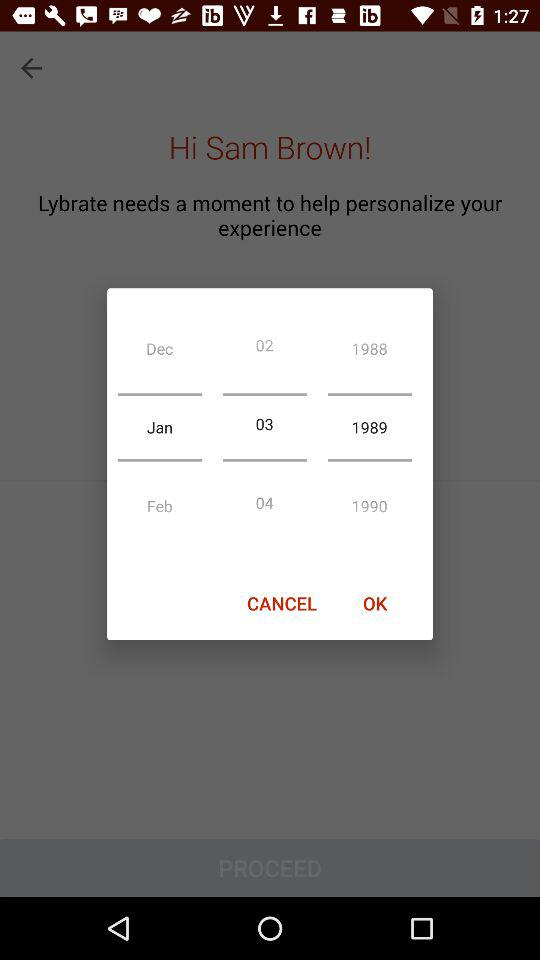What date is set in the calendar? The set date is January 3, 1989. 